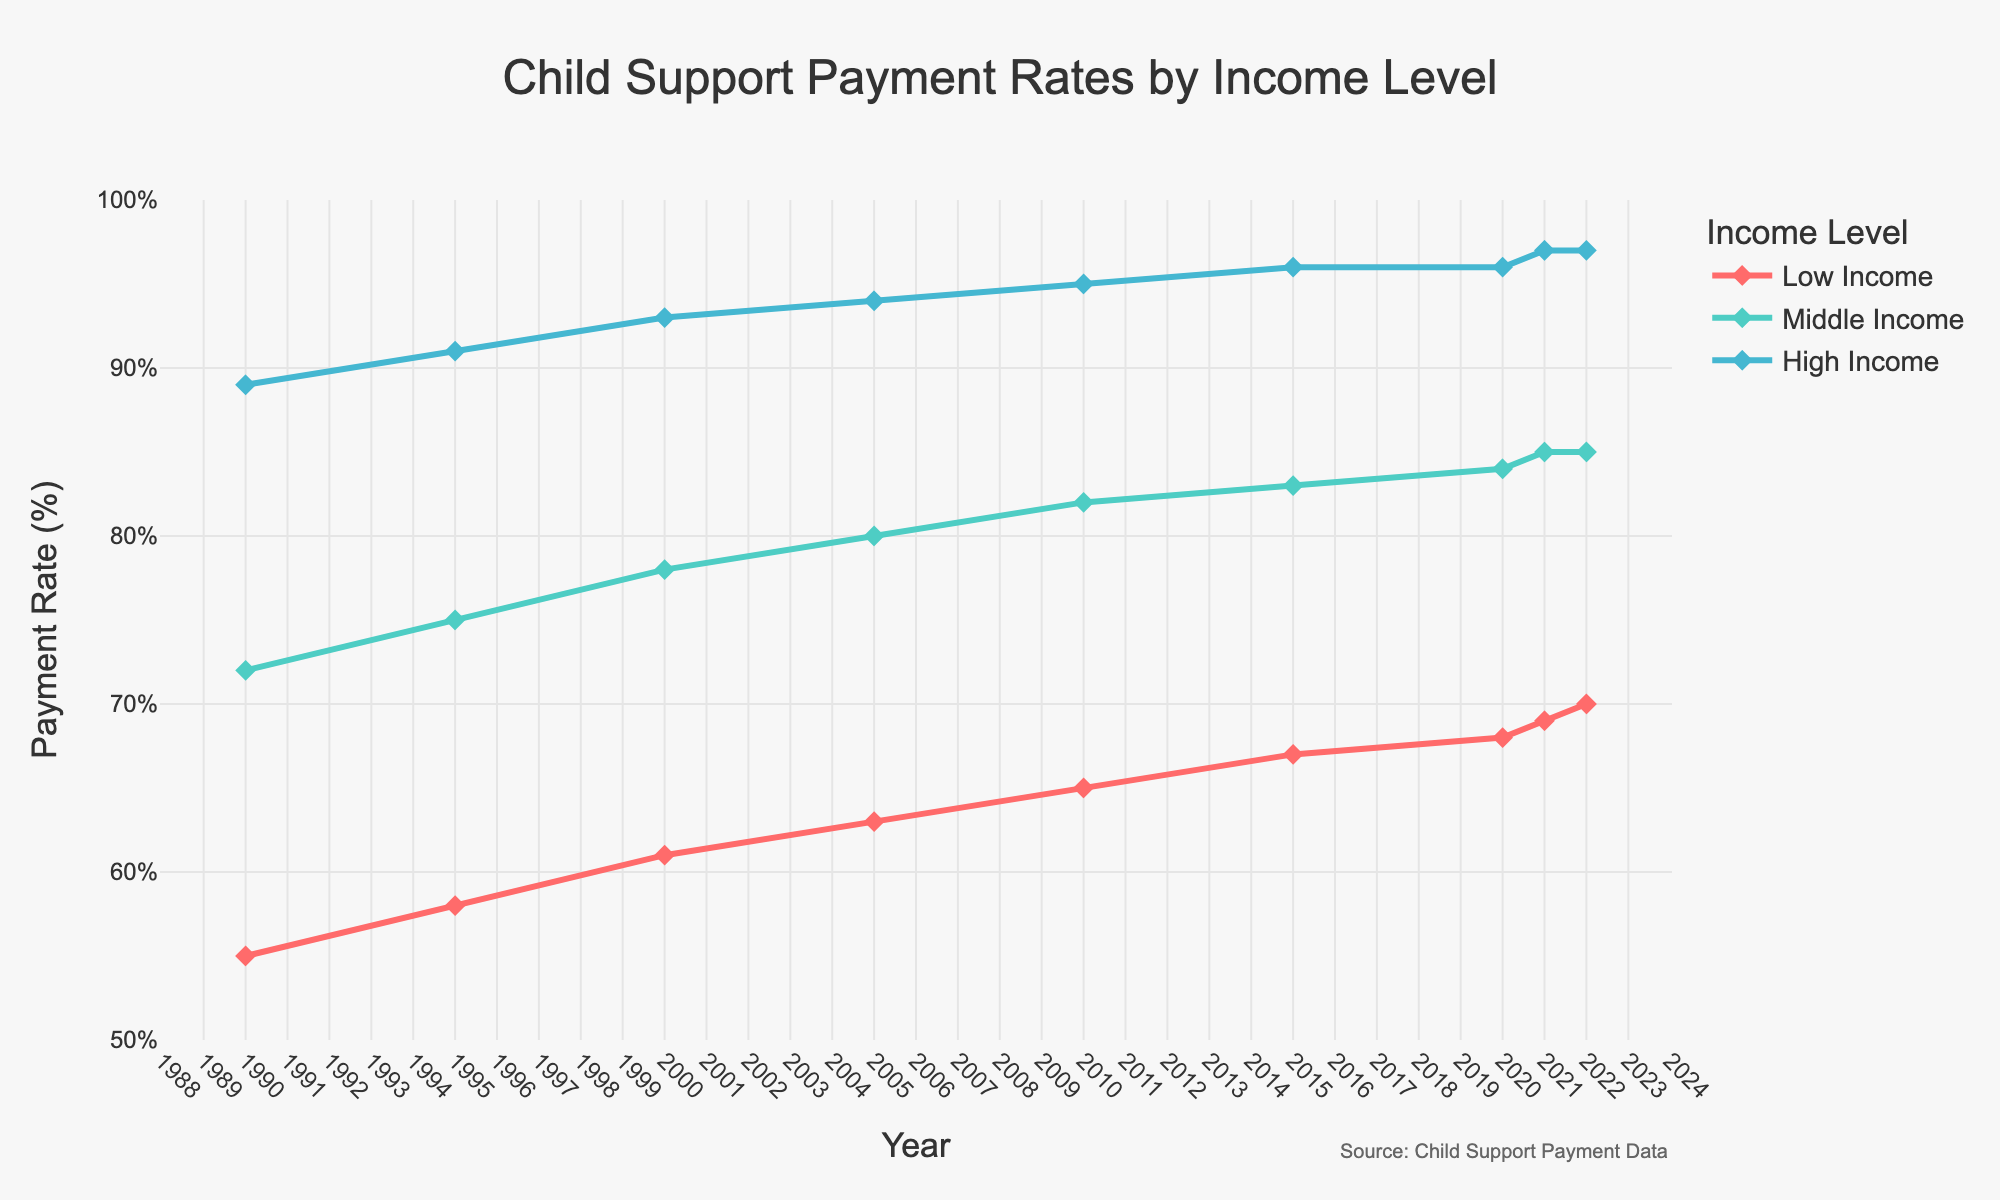Which income level shows the highest child support payment rate in 2022? The lines on the graph show that in 2022, the rate for High Income is above those for Middle and Low Income.
Answer: High Income How much did the child support payment rate for Low Income families increase from 1990 to 2022? On the graph, the Low Income line starts at 55% in 1990 and rises to 70% in 2022. The increase is 70% - 55% = 15%.
Answer: 15% What is the difference in child support payment rates between High Income and Low Income families in 2000? On the graph, the High Income rate in 2000 is 93%, and the Low Income rate is 61%. The difference is 93% - 61% = 32%.
Answer: 32% Which income level showed the most significant percentage increase in child support payment rate from 1990 to 2022? Calculate the percentage increase for each income level. Low Income: (70-55)/55 = 27.27%, Middle Income: (85-72)/72 = 18.06%, High Income: (97-89)/89 = 8.99%. Low Income has the highest percentage increase.
Answer: Low Income How does the child support payment rate in 2015 compare between Middle Income and High Income families? From the graph, in 2015, the Middle Income rate is 83%, and the High Income rate is 96%. The High Income rate is higher than Middle Income by 96% - 83% = 13%.
Answer: High Income by 13% What is the average child support payment rate for High Income families from 1990 to 2022? The rates are 89, 91, 93, 94, 95, 96, 96, 97, 97. Add them up (89+91+93+94+95+96+96+97+97 = 848) and divide by 9. The average is 848/9 = 94.22%.
Answer: 94.22% In which year did the Middle Income level reach an 80% payment rate? According to the graph, the Middle Income line crosses the 80% mark in 2005.
Answer: 2005 By how much did the child support payment rate for Middle Income families increase between 2010 and 2015? In 2010, the rate was 82%, and in 2015 it was 83%. The increase is 83% - 82% = 1%.
Answer: 1% Compare the trends in child support payment rates between Low and Middle Income families from 1990 to 2022. Both Low and Middle Income lines are increasing over time, but the Low Income rate starts lower and increases at a faster absolute rate.
Answer: Both increasing, Low Income faster Which income level has the smallest change in child support payment rate between 1990 and 2022? Calculate the rate change for each income level. Low Income: 15%, Middle Income: 13%, High Income: 8%. The High Income has the smallest change.
Answer: High Income 